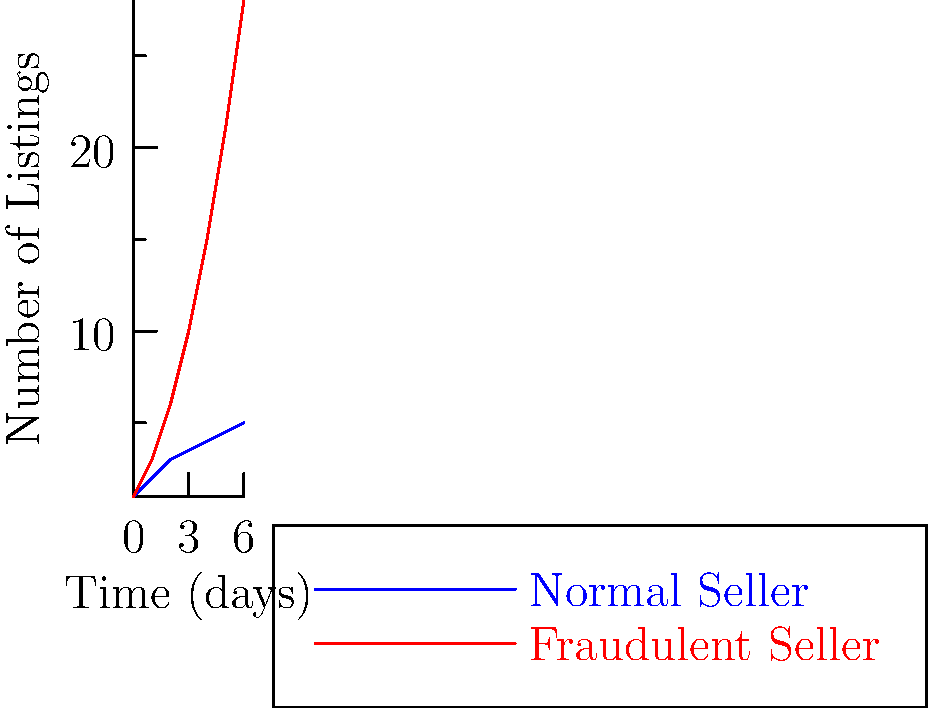Based on the behavioral pattern chart showing listing activity over time, which line is more likely to represent a fraudulent seller on eBay, and why? To determine which line represents a fraudulent seller, we need to analyze the patterns in the chart:

1. Blue line (Normal Seller):
   - Shows a gradual, linear increase in listings over time
   - Starts at 1 listing and reaches 5 listings by day 6
   - The rate of increase is relatively slow and consistent

2. Red line (Fraudulent Seller):
   - Exhibits an exponential growth in listings over time
   - Starts at 1 listing but rapidly increases to 28 listings by day 6
   - The rate of increase accelerates dramatically

3. Characteristics of fraudulent behavior:
   - Sudden surge in activity
   - Abnormally high number of listings in a short period
   - Exponential growth pattern

4. Analysis:
   - The red line shows a much steeper increase in listings
   - By day 6, the red line has 5.6 times more listings than the blue line
   - The exponential growth of the red line is typical of fraudulent activity

5. eBay fraud detection:
   - eBay's systems often flag accounts with unusually rapid increases in listing activity
   - The pattern shown by the red line would likely trigger fraud detection algorithms

Therefore, the red line is more likely to represent a fraudulent seller due to its exponential growth and unusually high number of listings in a short time frame.
Answer: Red line (exponential growth pattern) 